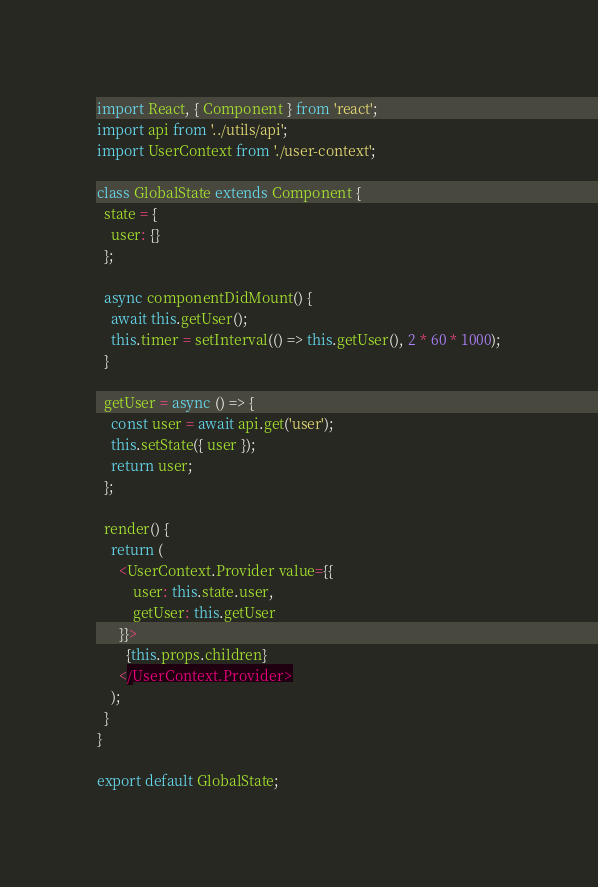Convert code to text. <code><loc_0><loc_0><loc_500><loc_500><_JavaScript_>import React, { Component } from 'react';
import api from '../utils/api';
import UserContext from './user-context';

class GlobalState extends Component {
  state = {
    user: {}
  };

  async componentDidMount() {
    await this.getUser();
    this.timer = setInterval(() => this.getUser(), 2 * 60 * 1000);
  }

  getUser = async () => {
    const user = await api.get('user');
    this.setState({ user });
    return user;
  };

  render() {
    return (
      <UserContext.Provider value={{
          user: this.state.user,
          getUser: this.getUser
      }}>
        {this.props.children}
      </UserContext.Provider>
    );
  }
}

export default GlobalState;</code> 